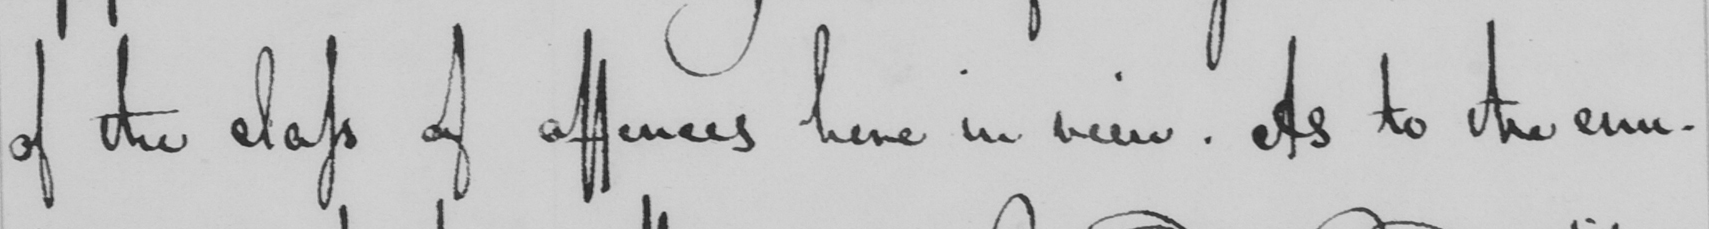What does this handwritten line say? of the class of offences here in view. As to the enu- 